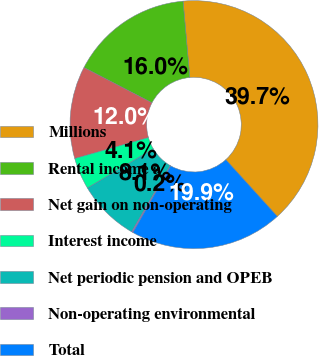<chart> <loc_0><loc_0><loc_500><loc_500><pie_chart><fcel>Millions<fcel>Rental income a<fcel>Net gain on non-operating<fcel>Interest income<fcel>Net periodic pension and OPEB<fcel>Non-operating environmental<fcel>Total<nl><fcel>39.68%<fcel>15.98%<fcel>12.03%<fcel>4.13%<fcel>8.08%<fcel>0.18%<fcel>19.93%<nl></chart> 